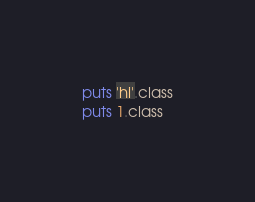Convert code to text. <code><loc_0><loc_0><loc_500><loc_500><_Ruby_>puts 'hi'.class
puts 1.class
</code> 